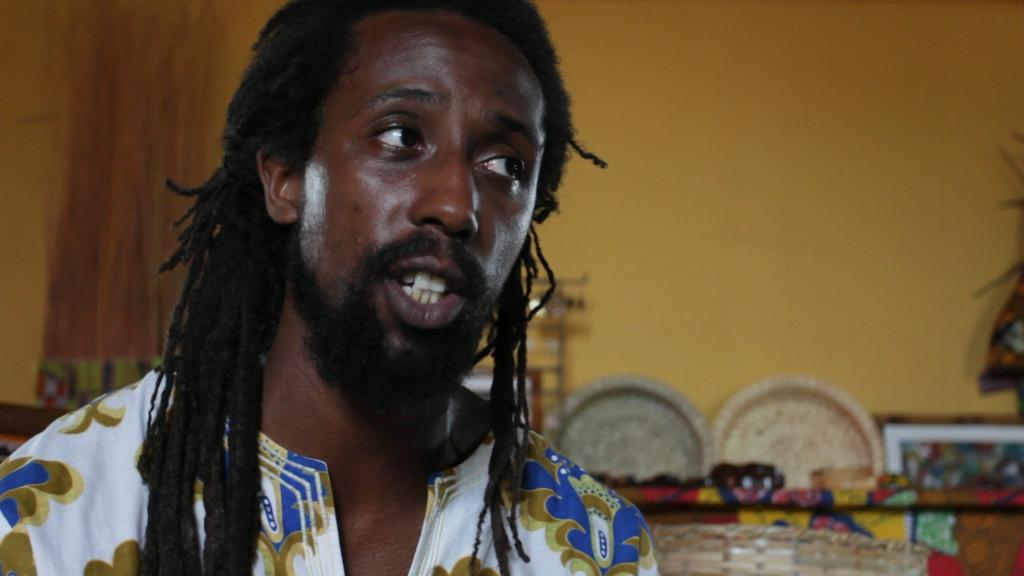Who is present in the image? There is a man in the image. What can be seen behind the man? There are objects visible behind the man. What type of structure is in the image? There is a wall in the image. How many pages are visible in the image? There are no pages present in the image. What type of basket is being used by the man in the image? There is no basket present in the image. 